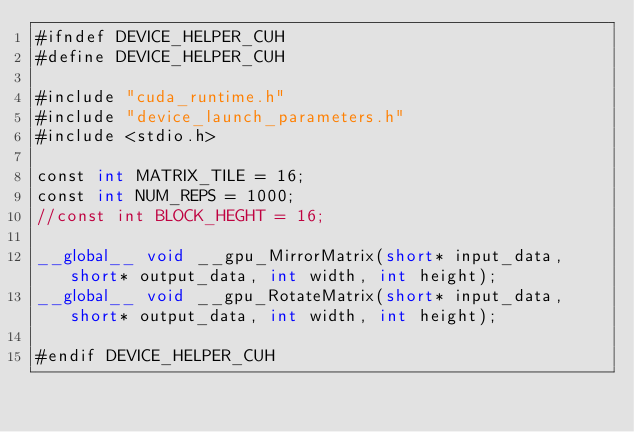<code> <loc_0><loc_0><loc_500><loc_500><_Cuda_>#ifndef DEVICE_HELPER_CUH
#define DEVICE_HELPER_CUH

#include "cuda_runtime.h"
#include "device_launch_parameters.h"
#include <stdio.h>

const int MATRIX_TILE = 16;
const int NUM_REPS = 1000;
//const int BLOCK_HEGHT = 16;

__global__ void __gpu_MirrorMatrix(short* input_data, short* output_data, int width, int height);
__global__ void __gpu_RotateMatrix(short* input_data, short* output_data, int width, int height);

#endif DEVICE_HELPER_CUH</code> 